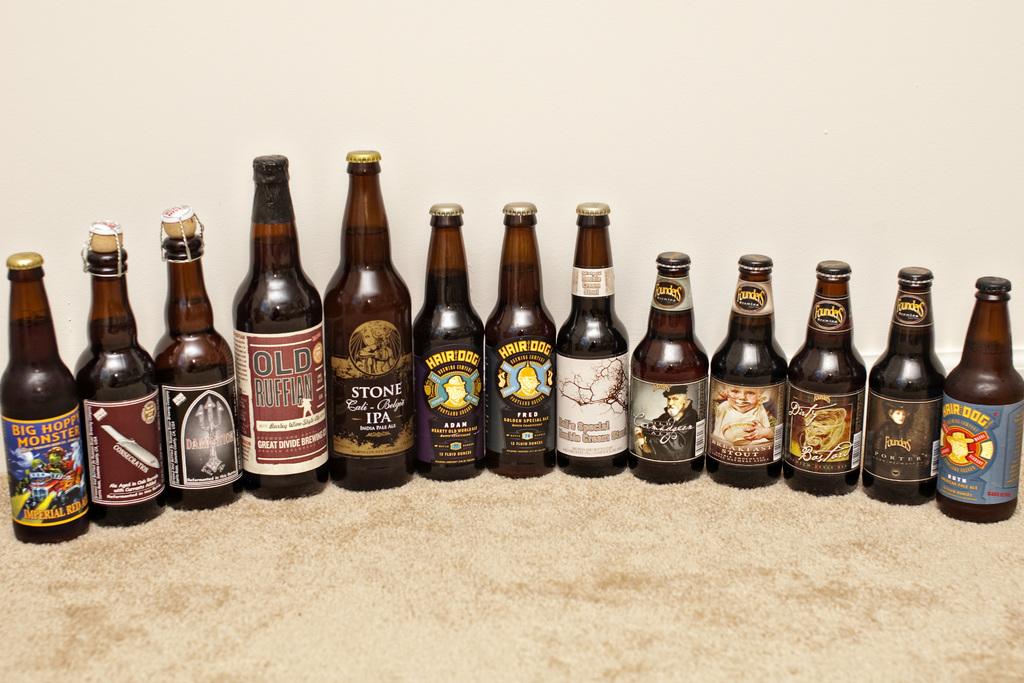What is the beer on the left?
Provide a short and direct response. Big hoppy monster. How many bottle of beers are in the picture?
Your answer should be very brief. Answering does not require reading text in the image. 